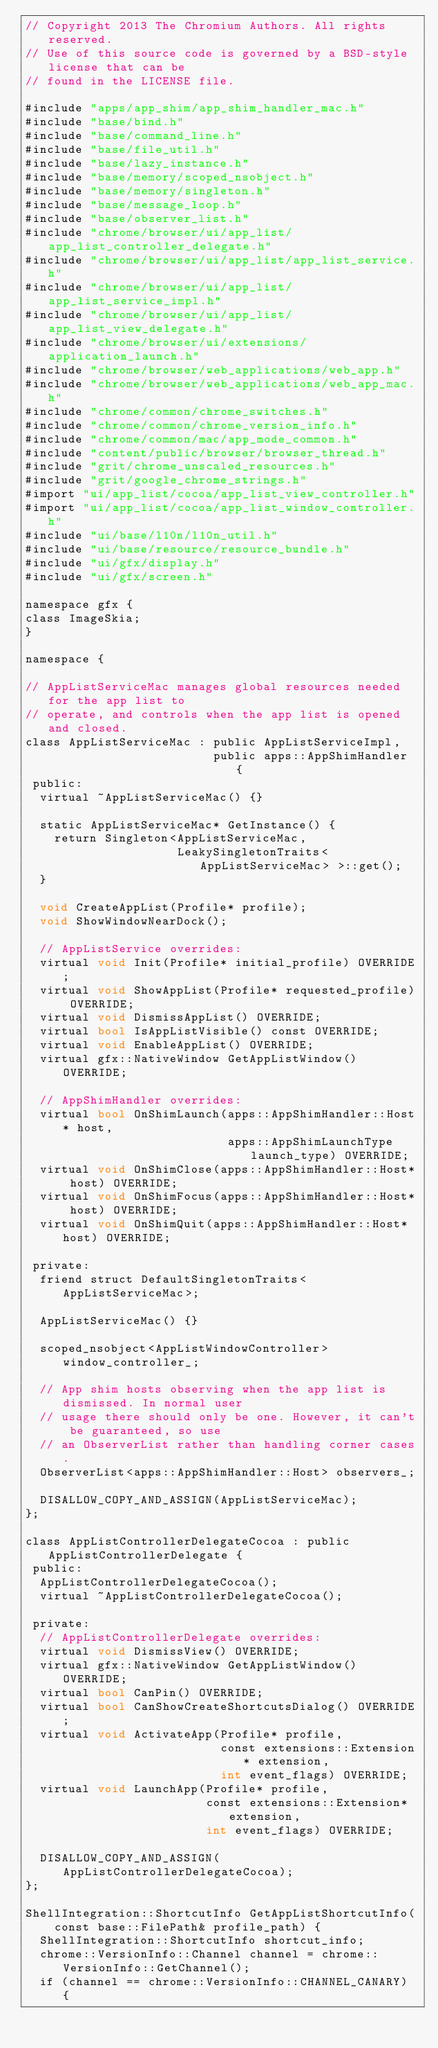<code> <loc_0><loc_0><loc_500><loc_500><_ObjectiveC_>// Copyright 2013 The Chromium Authors. All rights reserved.
// Use of this source code is governed by a BSD-style license that can be
// found in the LICENSE file.

#include "apps/app_shim/app_shim_handler_mac.h"
#include "base/bind.h"
#include "base/command_line.h"
#include "base/file_util.h"
#include "base/lazy_instance.h"
#include "base/memory/scoped_nsobject.h"
#include "base/memory/singleton.h"
#include "base/message_loop.h"
#include "base/observer_list.h"
#include "chrome/browser/ui/app_list/app_list_controller_delegate.h"
#include "chrome/browser/ui/app_list/app_list_service.h"
#include "chrome/browser/ui/app_list/app_list_service_impl.h"
#include "chrome/browser/ui/app_list/app_list_view_delegate.h"
#include "chrome/browser/ui/extensions/application_launch.h"
#include "chrome/browser/web_applications/web_app.h"
#include "chrome/browser/web_applications/web_app_mac.h"
#include "chrome/common/chrome_switches.h"
#include "chrome/common/chrome_version_info.h"
#include "chrome/common/mac/app_mode_common.h"
#include "content/public/browser/browser_thread.h"
#include "grit/chrome_unscaled_resources.h"
#include "grit/google_chrome_strings.h"
#import "ui/app_list/cocoa/app_list_view_controller.h"
#import "ui/app_list/cocoa/app_list_window_controller.h"
#include "ui/base/l10n/l10n_util.h"
#include "ui/base/resource/resource_bundle.h"
#include "ui/gfx/display.h"
#include "ui/gfx/screen.h"

namespace gfx {
class ImageSkia;
}

namespace {

// AppListServiceMac manages global resources needed for the app list to
// operate, and controls when the app list is opened and closed.
class AppListServiceMac : public AppListServiceImpl,
                          public apps::AppShimHandler {
 public:
  virtual ~AppListServiceMac() {}

  static AppListServiceMac* GetInstance() {
    return Singleton<AppListServiceMac,
                     LeakySingletonTraits<AppListServiceMac> >::get();
  }

  void CreateAppList(Profile* profile);
  void ShowWindowNearDock();

  // AppListService overrides:
  virtual void Init(Profile* initial_profile) OVERRIDE;
  virtual void ShowAppList(Profile* requested_profile) OVERRIDE;
  virtual void DismissAppList() OVERRIDE;
  virtual bool IsAppListVisible() const OVERRIDE;
  virtual void EnableAppList() OVERRIDE;
  virtual gfx::NativeWindow GetAppListWindow() OVERRIDE;

  // AppShimHandler overrides:
  virtual bool OnShimLaunch(apps::AppShimHandler::Host* host,
                            apps::AppShimLaunchType launch_type) OVERRIDE;
  virtual void OnShimClose(apps::AppShimHandler::Host* host) OVERRIDE;
  virtual void OnShimFocus(apps::AppShimHandler::Host* host) OVERRIDE;
  virtual void OnShimQuit(apps::AppShimHandler::Host* host) OVERRIDE;

 private:
  friend struct DefaultSingletonTraits<AppListServiceMac>;

  AppListServiceMac() {}

  scoped_nsobject<AppListWindowController> window_controller_;

  // App shim hosts observing when the app list is dismissed. In normal user
  // usage there should only be one. However, it can't be guaranteed, so use
  // an ObserverList rather than handling corner cases.
  ObserverList<apps::AppShimHandler::Host> observers_;

  DISALLOW_COPY_AND_ASSIGN(AppListServiceMac);
};

class AppListControllerDelegateCocoa : public AppListControllerDelegate {
 public:
  AppListControllerDelegateCocoa();
  virtual ~AppListControllerDelegateCocoa();

 private:
  // AppListControllerDelegate overrides:
  virtual void DismissView() OVERRIDE;
  virtual gfx::NativeWindow GetAppListWindow() OVERRIDE;
  virtual bool CanPin() OVERRIDE;
  virtual bool CanShowCreateShortcutsDialog() OVERRIDE;
  virtual void ActivateApp(Profile* profile,
                           const extensions::Extension* extension,
                           int event_flags) OVERRIDE;
  virtual void LaunchApp(Profile* profile,
                         const extensions::Extension* extension,
                         int event_flags) OVERRIDE;

  DISALLOW_COPY_AND_ASSIGN(AppListControllerDelegateCocoa);
};

ShellIntegration::ShortcutInfo GetAppListShortcutInfo(
    const base::FilePath& profile_path) {
  ShellIntegration::ShortcutInfo shortcut_info;
  chrome::VersionInfo::Channel channel = chrome::VersionInfo::GetChannel();
  if (channel == chrome::VersionInfo::CHANNEL_CANARY) {</code> 